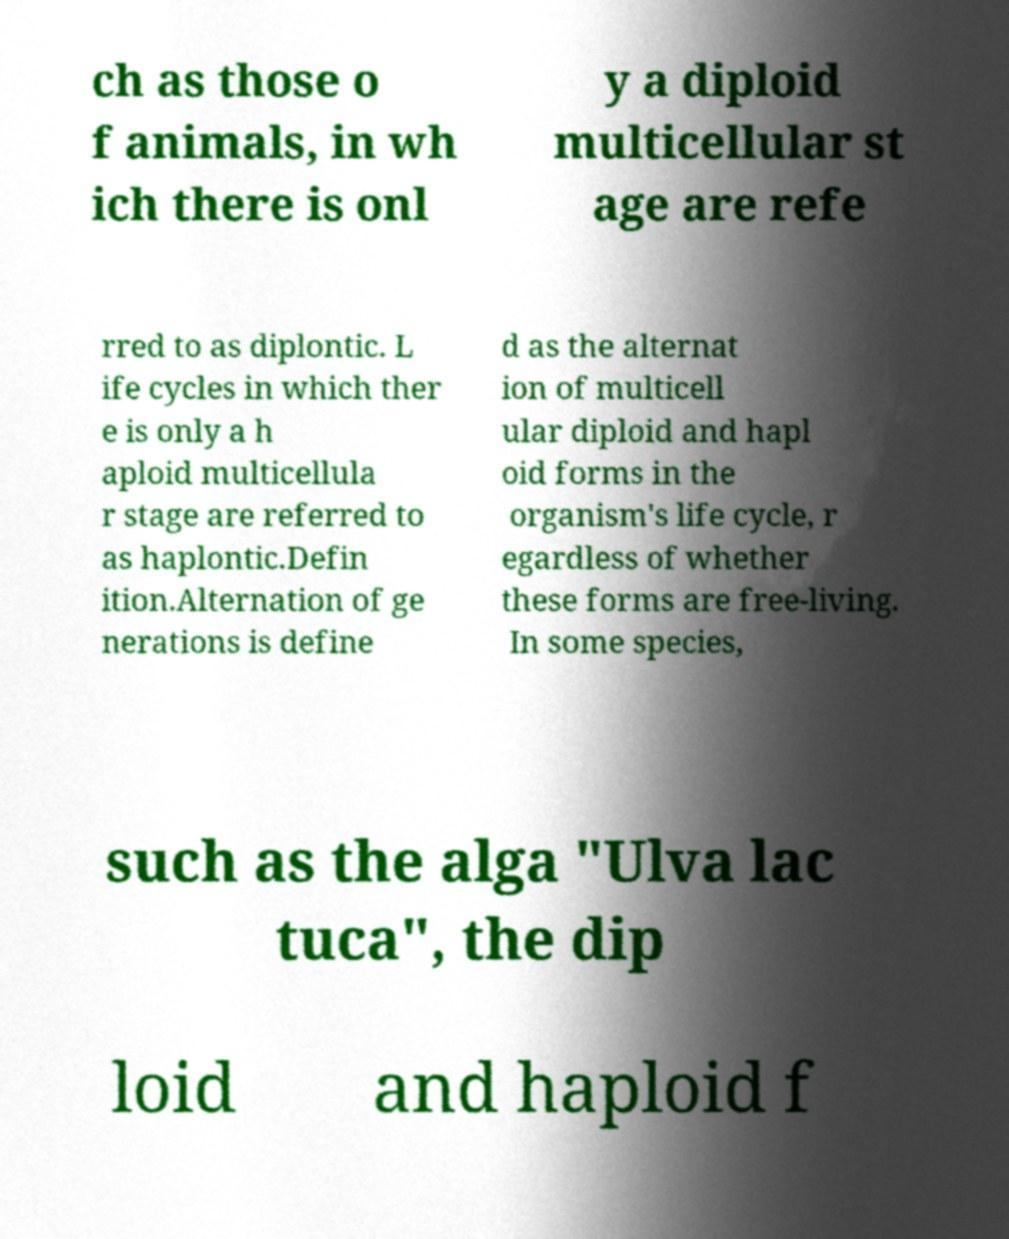Please read and relay the text visible in this image. What does it say? ch as those o f animals, in wh ich there is onl y a diploid multicellular st age are refe rred to as diplontic. L ife cycles in which ther e is only a h aploid multicellula r stage are referred to as haplontic.Defin ition.Alternation of ge nerations is define d as the alternat ion of multicell ular diploid and hapl oid forms in the organism's life cycle, r egardless of whether these forms are free-living. In some species, such as the alga "Ulva lac tuca", the dip loid and haploid f 